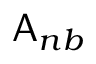<formula> <loc_0><loc_0><loc_500><loc_500>A _ { n b }</formula> 